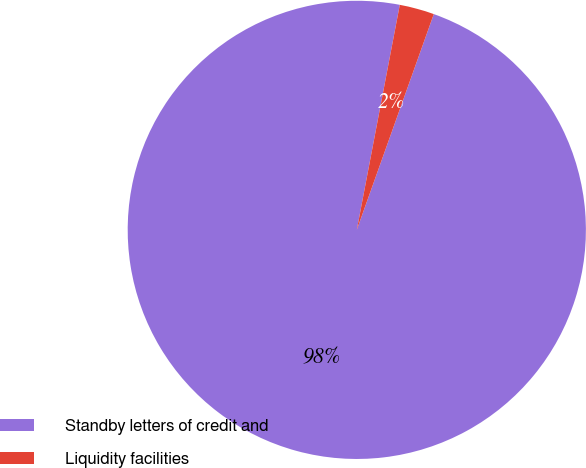Convert chart. <chart><loc_0><loc_0><loc_500><loc_500><pie_chart><fcel>Standby letters of credit and<fcel>Liquidity facilities<nl><fcel>97.55%<fcel>2.45%<nl></chart> 